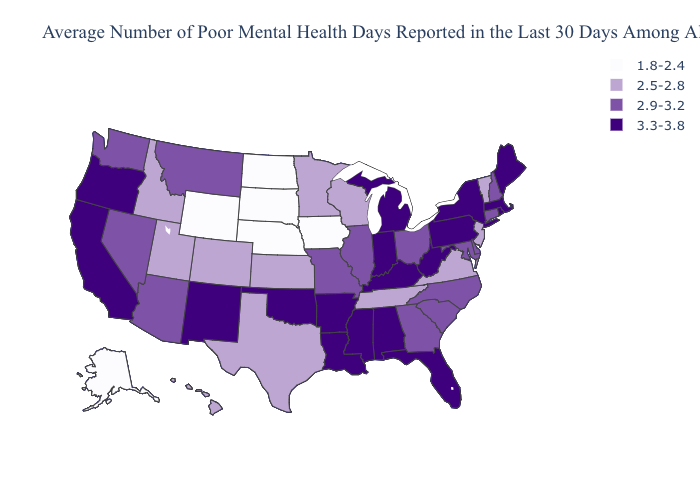Name the states that have a value in the range 2.9-3.2?
Quick response, please. Arizona, Connecticut, Delaware, Georgia, Illinois, Maryland, Missouri, Montana, Nevada, New Hampshire, North Carolina, Ohio, South Carolina, Washington. Does the map have missing data?
Quick response, please. No. Name the states that have a value in the range 3.3-3.8?
Short answer required. Alabama, Arkansas, California, Florida, Indiana, Kentucky, Louisiana, Maine, Massachusetts, Michigan, Mississippi, New Mexico, New York, Oklahoma, Oregon, Pennsylvania, Rhode Island, West Virginia. Name the states that have a value in the range 2.5-2.8?
Concise answer only. Colorado, Hawaii, Idaho, Kansas, Minnesota, New Jersey, Tennessee, Texas, Utah, Vermont, Virginia, Wisconsin. Does the map have missing data?
Answer briefly. No. What is the lowest value in the USA?
Concise answer only. 1.8-2.4. What is the value of New Mexico?
Concise answer only. 3.3-3.8. Name the states that have a value in the range 3.3-3.8?
Concise answer only. Alabama, Arkansas, California, Florida, Indiana, Kentucky, Louisiana, Maine, Massachusetts, Michigan, Mississippi, New Mexico, New York, Oklahoma, Oregon, Pennsylvania, Rhode Island, West Virginia. Does Nebraska have the lowest value in the USA?
Write a very short answer. Yes. Name the states that have a value in the range 1.8-2.4?
Give a very brief answer. Alaska, Iowa, Nebraska, North Dakota, South Dakota, Wyoming. Does Nevada have the same value as Kentucky?
Be succinct. No. What is the value of Pennsylvania?
Keep it brief. 3.3-3.8. Among the states that border Indiana , which have the lowest value?
Write a very short answer. Illinois, Ohio. Name the states that have a value in the range 1.8-2.4?
Answer briefly. Alaska, Iowa, Nebraska, North Dakota, South Dakota, Wyoming. Among the states that border New Hampshire , does Maine have the lowest value?
Give a very brief answer. No. 